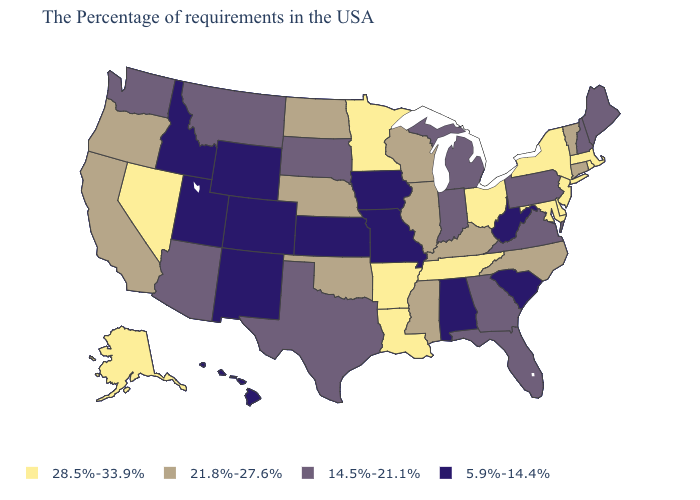Does Missouri have a higher value than Georgia?
Write a very short answer. No. Name the states that have a value in the range 28.5%-33.9%?
Be succinct. Massachusetts, Rhode Island, New York, New Jersey, Delaware, Maryland, Ohio, Tennessee, Louisiana, Arkansas, Minnesota, Nevada, Alaska. What is the value of Colorado?
Write a very short answer. 5.9%-14.4%. Is the legend a continuous bar?
Quick response, please. No. How many symbols are there in the legend?
Answer briefly. 4. Name the states that have a value in the range 28.5%-33.9%?
Short answer required. Massachusetts, Rhode Island, New York, New Jersey, Delaware, Maryland, Ohio, Tennessee, Louisiana, Arkansas, Minnesota, Nevada, Alaska. Does New Jersey have the lowest value in the Northeast?
Give a very brief answer. No. Name the states that have a value in the range 5.9%-14.4%?
Answer briefly. South Carolina, West Virginia, Alabama, Missouri, Iowa, Kansas, Wyoming, Colorado, New Mexico, Utah, Idaho, Hawaii. Does Alabama have the same value as Michigan?
Answer briefly. No. Name the states that have a value in the range 28.5%-33.9%?
Concise answer only. Massachusetts, Rhode Island, New York, New Jersey, Delaware, Maryland, Ohio, Tennessee, Louisiana, Arkansas, Minnesota, Nevada, Alaska. What is the lowest value in states that border Rhode Island?
Be succinct. 21.8%-27.6%. What is the highest value in the USA?
Give a very brief answer. 28.5%-33.9%. What is the value of Wyoming?
Concise answer only. 5.9%-14.4%. What is the value of Illinois?
Be succinct. 21.8%-27.6%. What is the value of New York?
Quick response, please. 28.5%-33.9%. 